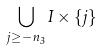Convert formula to latex. <formula><loc_0><loc_0><loc_500><loc_500>\bigcup _ { j \geq - n _ { 3 } } I \times \{ j \}</formula> 